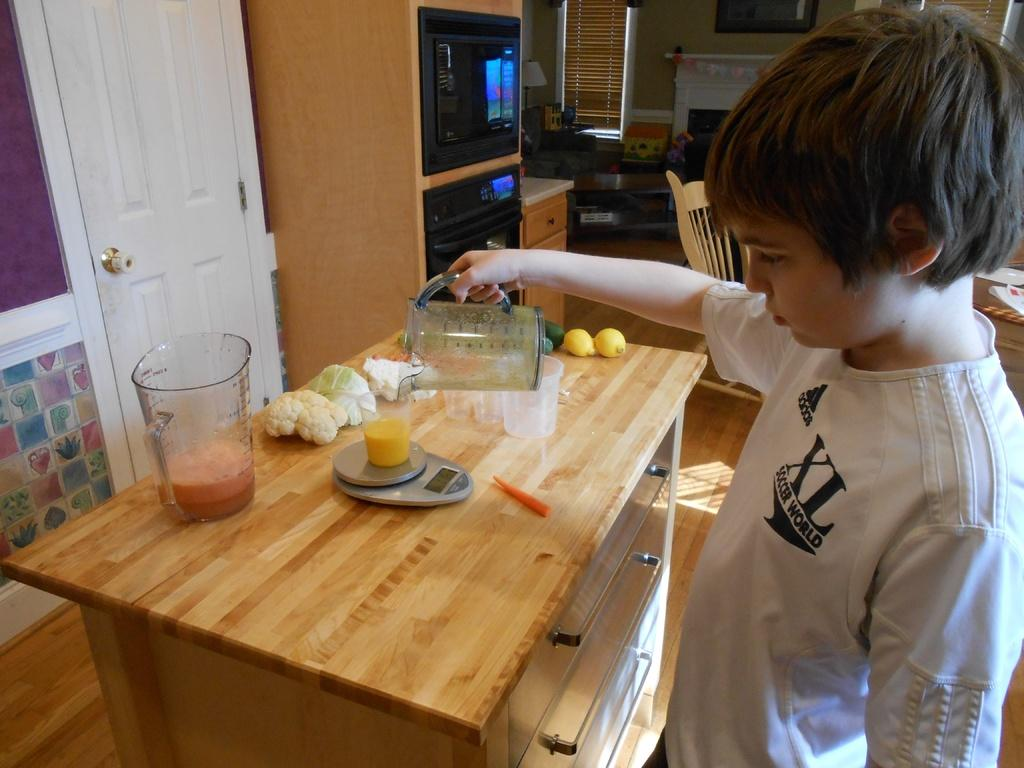<image>
Render a clear and concise summary of the photo. A young boy wearing a shirt with ingrained XL Soccer world is pouring the content of  a blender into a cup. 